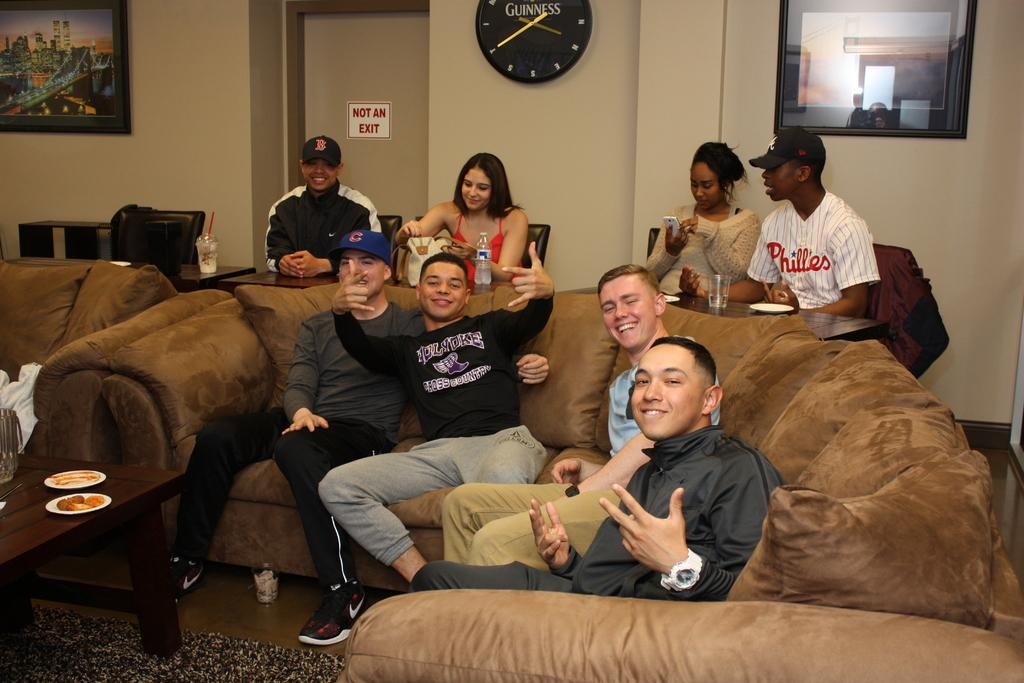<image>
Create a compact narrative representing the image presented. a not an exit sign that is on a door 